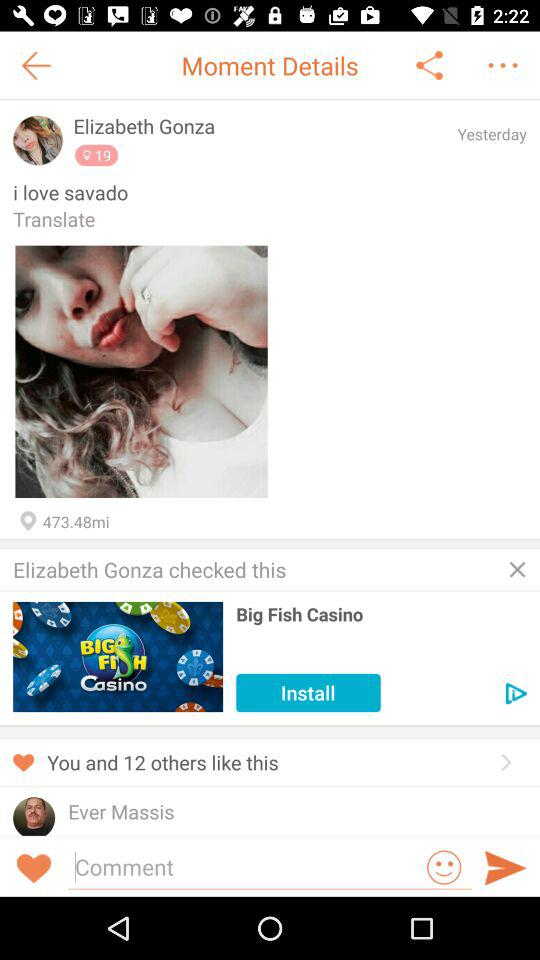How many likes on Elizabeth's post?
When the provided information is insufficient, respond with <no answer>. <no answer> 